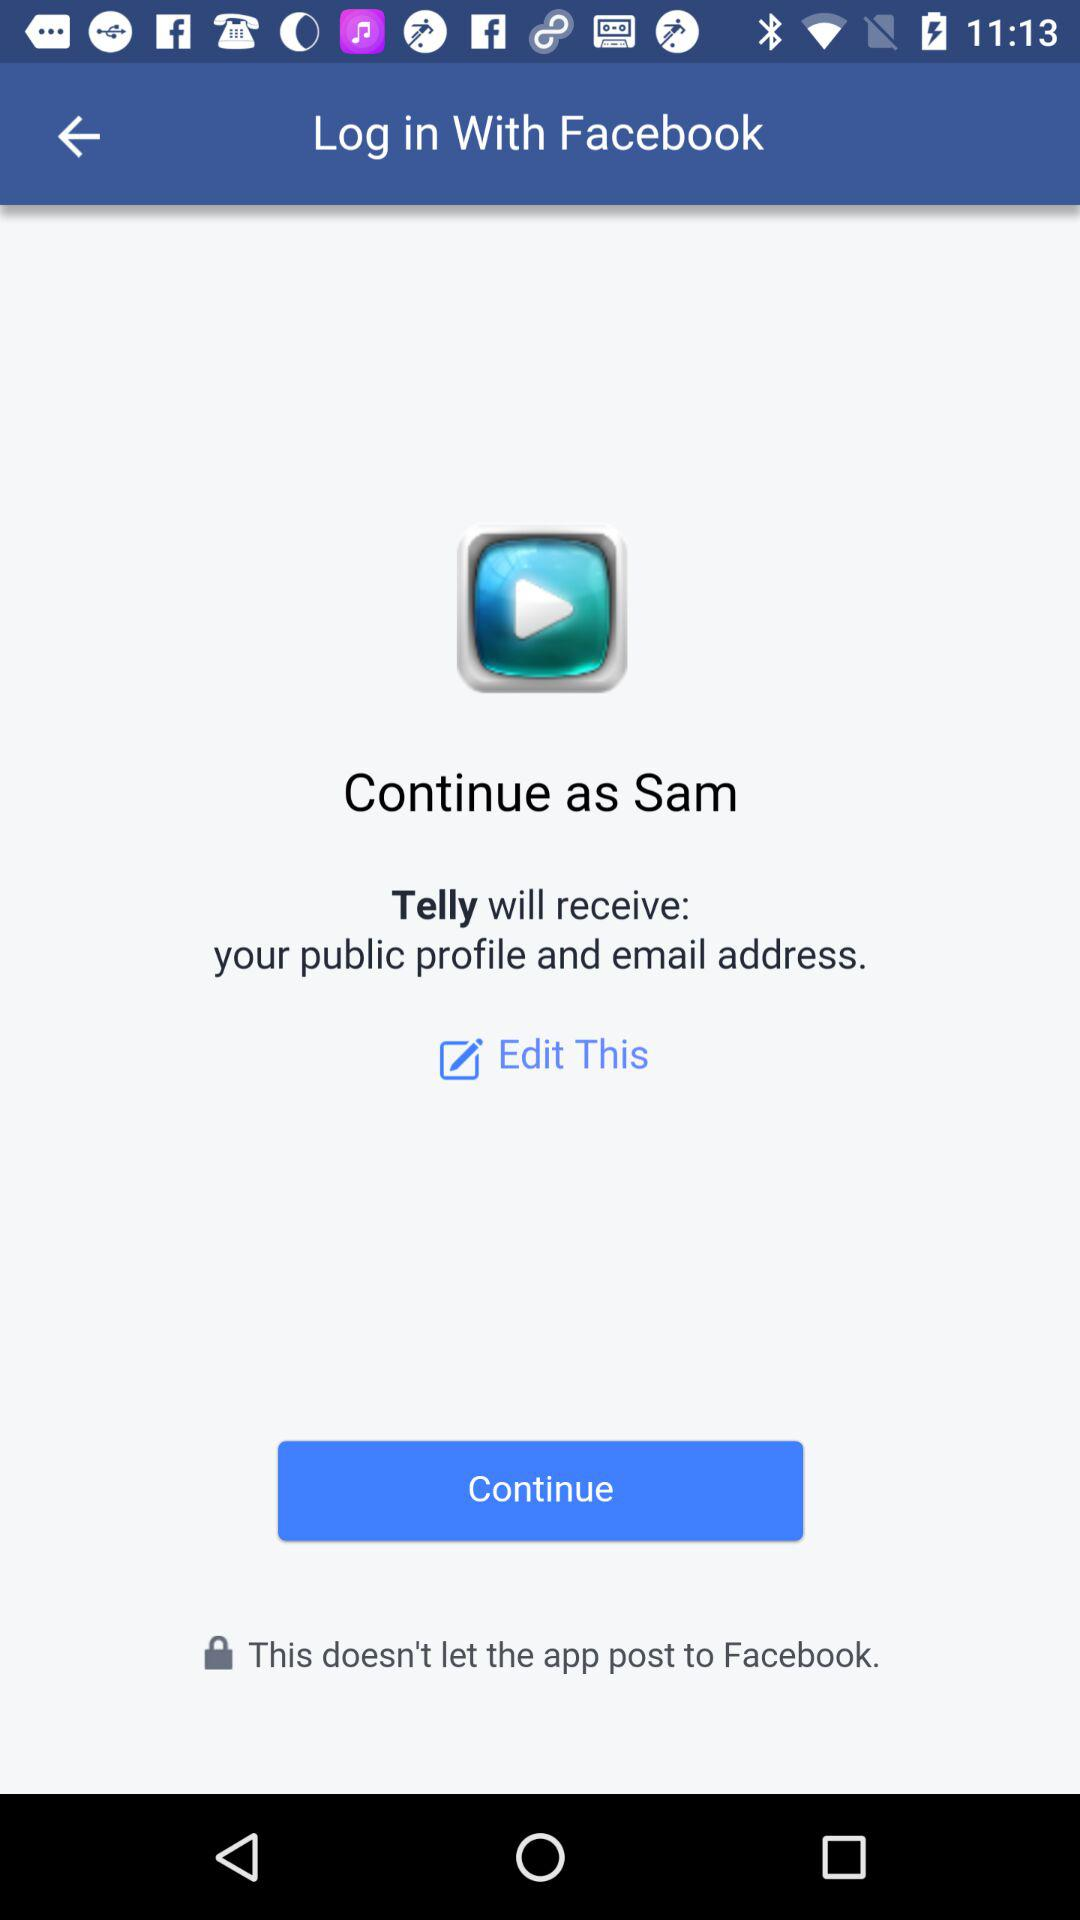What is the name of the user? The name of the user is Sam. 